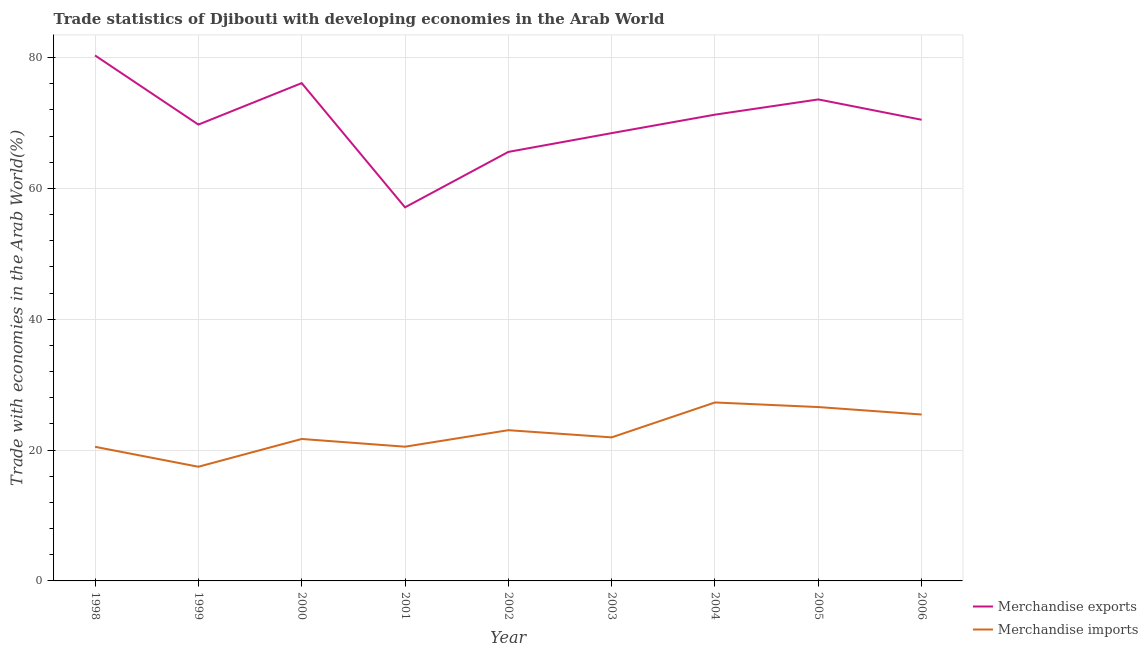What is the merchandise exports in 2002?
Ensure brevity in your answer.  65.59. Across all years, what is the maximum merchandise imports?
Provide a succinct answer. 27.28. Across all years, what is the minimum merchandise imports?
Your response must be concise. 17.46. In which year was the merchandise imports minimum?
Give a very brief answer. 1999. What is the total merchandise imports in the graph?
Ensure brevity in your answer.  204.48. What is the difference between the merchandise exports in 1998 and that in 2004?
Your response must be concise. 9.05. What is the difference between the merchandise imports in 1998 and the merchandise exports in 2001?
Your response must be concise. -36.61. What is the average merchandise exports per year?
Ensure brevity in your answer.  70.31. In the year 1999, what is the difference between the merchandise imports and merchandise exports?
Ensure brevity in your answer.  -52.31. What is the ratio of the merchandise imports in 2005 to that in 2006?
Offer a terse response. 1.04. Is the merchandise imports in 2000 less than that in 2004?
Make the answer very short. Yes. Is the difference between the merchandise exports in 2000 and 2003 greater than the difference between the merchandise imports in 2000 and 2003?
Give a very brief answer. Yes. What is the difference between the highest and the second highest merchandise exports?
Offer a very short reply. 4.23. What is the difference between the highest and the lowest merchandise imports?
Offer a terse response. 9.83. Is the sum of the merchandise imports in 2000 and 2003 greater than the maximum merchandise exports across all years?
Give a very brief answer. No. How many lines are there?
Provide a short and direct response. 2. Are the values on the major ticks of Y-axis written in scientific E-notation?
Provide a short and direct response. No. Where does the legend appear in the graph?
Provide a succinct answer. Bottom right. How many legend labels are there?
Offer a very short reply. 2. How are the legend labels stacked?
Your answer should be very brief. Vertical. What is the title of the graph?
Provide a succinct answer. Trade statistics of Djibouti with developing economies in the Arab World. Does "constant 2005 US$" appear as one of the legend labels in the graph?
Offer a terse response. No. What is the label or title of the Y-axis?
Give a very brief answer. Trade with economies in the Arab World(%). What is the Trade with economies in the Arab World(%) in Merchandise exports in 1998?
Provide a short and direct response. 80.34. What is the Trade with economies in the Arab World(%) of Merchandise imports in 1998?
Provide a succinct answer. 20.51. What is the Trade with economies in the Arab World(%) in Merchandise exports in 1999?
Make the answer very short. 69.77. What is the Trade with economies in the Arab World(%) of Merchandise imports in 1999?
Your answer should be compact. 17.46. What is the Trade with economies in the Arab World(%) in Merchandise exports in 2000?
Your answer should be very brief. 76.11. What is the Trade with economies in the Arab World(%) in Merchandise imports in 2000?
Ensure brevity in your answer.  21.7. What is the Trade with economies in the Arab World(%) in Merchandise exports in 2001?
Your response must be concise. 57.12. What is the Trade with economies in the Arab World(%) of Merchandise imports in 2001?
Ensure brevity in your answer.  20.52. What is the Trade with economies in the Arab World(%) in Merchandise exports in 2002?
Ensure brevity in your answer.  65.59. What is the Trade with economies in the Arab World(%) of Merchandise imports in 2002?
Provide a short and direct response. 23.04. What is the Trade with economies in the Arab World(%) in Merchandise exports in 2003?
Provide a succinct answer. 68.46. What is the Trade with economies in the Arab World(%) in Merchandise imports in 2003?
Provide a short and direct response. 21.95. What is the Trade with economies in the Arab World(%) in Merchandise exports in 2004?
Provide a succinct answer. 71.29. What is the Trade with economies in the Arab World(%) of Merchandise imports in 2004?
Ensure brevity in your answer.  27.28. What is the Trade with economies in the Arab World(%) in Merchandise exports in 2005?
Provide a succinct answer. 73.61. What is the Trade with economies in the Arab World(%) in Merchandise imports in 2005?
Make the answer very short. 26.58. What is the Trade with economies in the Arab World(%) of Merchandise exports in 2006?
Make the answer very short. 70.5. What is the Trade with economies in the Arab World(%) in Merchandise imports in 2006?
Keep it short and to the point. 25.44. Across all years, what is the maximum Trade with economies in the Arab World(%) of Merchandise exports?
Provide a short and direct response. 80.34. Across all years, what is the maximum Trade with economies in the Arab World(%) of Merchandise imports?
Offer a very short reply. 27.28. Across all years, what is the minimum Trade with economies in the Arab World(%) of Merchandise exports?
Provide a short and direct response. 57.12. Across all years, what is the minimum Trade with economies in the Arab World(%) in Merchandise imports?
Make the answer very short. 17.46. What is the total Trade with economies in the Arab World(%) of Merchandise exports in the graph?
Make the answer very short. 632.78. What is the total Trade with economies in the Arab World(%) in Merchandise imports in the graph?
Provide a short and direct response. 204.48. What is the difference between the Trade with economies in the Arab World(%) of Merchandise exports in 1998 and that in 1999?
Your answer should be very brief. 10.57. What is the difference between the Trade with economies in the Arab World(%) in Merchandise imports in 1998 and that in 1999?
Give a very brief answer. 3.05. What is the difference between the Trade with economies in the Arab World(%) in Merchandise exports in 1998 and that in 2000?
Give a very brief answer. 4.23. What is the difference between the Trade with economies in the Arab World(%) in Merchandise imports in 1998 and that in 2000?
Offer a very short reply. -1.2. What is the difference between the Trade with economies in the Arab World(%) in Merchandise exports in 1998 and that in 2001?
Provide a succinct answer. 23.22. What is the difference between the Trade with economies in the Arab World(%) of Merchandise imports in 1998 and that in 2001?
Your response must be concise. -0.02. What is the difference between the Trade with economies in the Arab World(%) of Merchandise exports in 1998 and that in 2002?
Make the answer very short. 14.75. What is the difference between the Trade with economies in the Arab World(%) of Merchandise imports in 1998 and that in 2002?
Offer a terse response. -2.54. What is the difference between the Trade with economies in the Arab World(%) of Merchandise exports in 1998 and that in 2003?
Give a very brief answer. 11.88. What is the difference between the Trade with economies in the Arab World(%) of Merchandise imports in 1998 and that in 2003?
Ensure brevity in your answer.  -1.44. What is the difference between the Trade with economies in the Arab World(%) of Merchandise exports in 1998 and that in 2004?
Keep it short and to the point. 9.05. What is the difference between the Trade with economies in the Arab World(%) in Merchandise imports in 1998 and that in 2004?
Keep it short and to the point. -6.78. What is the difference between the Trade with economies in the Arab World(%) of Merchandise exports in 1998 and that in 2005?
Give a very brief answer. 6.72. What is the difference between the Trade with economies in the Arab World(%) in Merchandise imports in 1998 and that in 2005?
Provide a succinct answer. -6.08. What is the difference between the Trade with economies in the Arab World(%) of Merchandise exports in 1998 and that in 2006?
Give a very brief answer. 9.84. What is the difference between the Trade with economies in the Arab World(%) of Merchandise imports in 1998 and that in 2006?
Ensure brevity in your answer.  -4.93. What is the difference between the Trade with economies in the Arab World(%) in Merchandise exports in 1999 and that in 2000?
Your answer should be compact. -6.34. What is the difference between the Trade with economies in the Arab World(%) of Merchandise imports in 1999 and that in 2000?
Your answer should be compact. -4.25. What is the difference between the Trade with economies in the Arab World(%) of Merchandise exports in 1999 and that in 2001?
Your response must be concise. 12.65. What is the difference between the Trade with economies in the Arab World(%) in Merchandise imports in 1999 and that in 2001?
Keep it short and to the point. -3.07. What is the difference between the Trade with economies in the Arab World(%) of Merchandise exports in 1999 and that in 2002?
Keep it short and to the point. 4.17. What is the difference between the Trade with economies in the Arab World(%) of Merchandise imports in 1999 and that in 2002?
Give a very brief answer. -5.59. What is the difference between the Trade with economies in the Arab World(%) in Merchandise exports in 1999 and that in 2003?
Provide a short and direct response. 1.3. What is the difference between the Trade with economies in the Arab World(%) of Merchandise imports in 1999 and that in 2003?
Keep it short and to the point. -4.49. What is the difference between the Trade with economies in the Arab World(%) of Merchandise exports in 1999 and that in 2004?
Provide a short and direct response. -1.52. What is the difference between the Trade with economies in the Arab World(%) in Merchandise imports in 1999 and that in 2004?
Your answer should be compact. -9.83. What is the difference between the Trade with economies in the Arab World(%) of Merchandise exports in 1999 and that in 2005?
Your answer should be compact. -3.85. What is the difference between the Trade with economies in the Arab World(%) of Merchandise imports in 1999 and that in 2005?
Keep it short and to the point. -9.13. What is the difference between the Trade with economies in the Arab World(%) in Merchandise exports in 1999 and that in 2006?
Keep it short and to the point. -0.74. What is the difference between the Trade with economies in the Arab World(%) of Merchandise imports in 1999 and that in 2006?
Ensure brevity in your answer.  -7.99. What is the difference between the Trade with economies in the Arab World(%) of Merchandise exports in 2000 and that in 2001?
Offer a terse response. 18.99. What is the difference between the Trade with economies in the Arab World(%) in Merchandise imports in 2000 and that in 2001?
Provide a succinct answer. 1.18. What is the difference between the Trade with economies in the Arab World(%) in Merchandise exports in 2000 and that in 2002?
Your answer should be compact. 10.52. What is the difference between the Trade with economies in the Arab World(%) in Merchandise imports in 2000 and that in 2002?
Provide a short and direct response. -1.34. What is the difference between the Trade with economies in the Arab World(%) in Merchandise exports in 2000 and that in 2003?
Your response must be concise. 7.65. What is the difference between the Trade with economies in the Arab World(%) in Merchandise imports in 2000 and that in 2003?
Provide a short and direct response. -0.24. What is the difference between the Trade with economies in the Arab World(%) of Merchandise exports in 2000 and that in 2004?
Ensure brevity in your answer.  4.82. What is the difference between the Trade with economies in the Arab World(%) in Merchandise imports in 2000 and that in 2004?
Provide a succinct answer. -5.58. What is the difference between the Trade with economies in the Arab World(%) of Merchandise exports in 2000 and that in 2005?
Ensure brevity in your answer.  2.49. What is the difference between the Trade with economies in the Arab World(%) of Merchandise imports in 2000 and that in 2005?
Your answer should be very brief. -4.88. What is the difference between the Trade with economies in the Arab World(%) of Merchandise exports in 2000 and that in 2006?
Make the answer very short. 5.6. What is the difference between the Trade with economies in the Arab World(%) in Merchandise imports in 2000 and that in 2006?
Your answer should be very brief. -3.74. What is the difference between the Trade with economies in the Arab World(%) in Merchandise exports in 2001 and that in 2002?
Provide a short and direct response. -8.47. What is the difference between the Trade with economies in the Arab World(%) in Merchandise imports in 2001 and that in 2002?
Your answer should be very brief. -2.52. What is the difference between the Trade with economies in the Arab World(%) of Merchandise exports in 2001 and that in 2003?
Give a very brief answer. -11.35. What is the difference between the Trade with economies in the Arab World(%) in Merchandise imports in 2001 and that in 2003?
Ensure brevity in your answer.  -1.43. What is the difference between the Trade with economies in the Arab World(%) of Merchandise exports in 2001 and that in 2004?
Give a very brief answer. -14.17. What is the difference between the Trade with economies in the Arab World(%) in Merchandise imports in 2001 and that in 2004?
Your response must be concise. -6.76. What is the difference between the Trade with economies in the Arab World(%) in Merchandise exports in 2001 and that in 2005?
Your answer should be very brief. -16.5. What is the difference between the Trade with economies in the Arab World(%) of Merchandise imports in 2001 and that in 2005?
Make the answer very short. -6.06. What is the difference between the Trade with economies in the Arab World(%) of Merchandise exports in 2001 and that in 2006?
Make the answer very short. -13.39. What is the difference between the Trade with economies in the Arab World(%) in Merchandise imports in 2001 and that in 2006?
Offer a terse response. -4.92. What is the difference between the Trade with economies in the Arab World(%) of Merchandise exports in 2002 and that in 2003?
Provide a short and direct response. -2.87. What is the difference between the Trade with economies in the Arab World(%) of Merchandise imports in 2002 and that in 2003?
Your answer should be compact. 1.1. What is the difference between the Trade with economies in the Arab World(%) in Merchandise exports in 2002 and that in 2004?
Give a very brief answer. -5.69. What is the difference between the Trade with economies in the Arab World(%) in Merchandise imports in 2002 and that in 2004?
Give a very brief answer. -4.24. What is the difference between the Trade with economies in the Arab World(%) in Merchandise exports in 2002 and that in 2005?
Make the answer very short. -8.02. What is the difference between the Trade with economies in the Arab World(%) of Merchandise imports in 2002 and that in 2005?
Ensure brevity in your answer.  -3.54. What is the difference between the Trade with economies in the Arab World(%) in Merchandise exports in 2002 and that in 2006?
Ensure brevity in your answer.  -4.91. What is the difference between the Trade with economies in the Arab World(%) of Merchandise imports in 2002 and that in 2006?
Make the answer very short. -2.4. What is the difference between the Trade with economies in the Arab World(%) of Merchandise exports in 2003 and that in 2004?
Keep it short and to the point. -2.82. What is the difference between the Trade with economies in the Arab World(%) in Merchandise imports in 2003 and that in 2004?
Your answer should be compact. -5.34. What is the difference between the Trade with economies in the Arab World(%) in Merchandise exports in 2003 and that in 2005?
Make the answer very short. -5.15. What is the difference between the Trade with economies in the Arab World(%) in Merchandise imports in 2003 and that in 2005?
Provide a short and direct response. -4.63. What is the difference between the Trade with economies in the Arab World(%) in Merchandise exports in 2003 and that in 2006?
Make the answer very short. -2.04. What is the difference between the Trade with economies in the Arab World(%) in Merchandise imports in 2003 and that in 2006?
Keep it short and to the point. -3.49. What is the difference between the Trade with economies in the Arab World(%) of Merchandise exports in 2004 and that in 2005?
Provide a succinct answer. -2.33. What is the difference between the Trade with economies in the Arab World(%) in Merchandise imports in 2004 and that in 2005?
Make the answer very short. 0.7. What is the difference between the Trade with economies in the Arab World(%) of Merchandise exports in 2004 and that in 2006?
Give a very brief answer. 0.78. What is the difference between the Trade with economies in the Arab World(%) of Merchandise imports in 2004 and that in 2006?
Offer a very short reply. 1.84. What is the difference between the Trade with economies in the Arab World(%) in Merchandise exports in 2005 and that in 2006?
Make the answer very short. 3.11. What is the difference between the Trade with economies in the Arab World(%) of Merchandise imports in 2005 and that in 2006?
Make the answer very short. 1.14. What is the difference between the Trade with economies in the Arab World(%) of Merchandise exports in 1998 and the Trade with economies in the Arab World(%) of Merchandise imports in 1999?
Make the answer very short. 62.88. What is the difference between the Trade with economies in the Arab World(%) in Merchandise exports in 1998 and the Trade with economies in the Arab World(%) in Merchandise imports in 2000?
Make the answer very short. 58.64. What is the difference between the Trade with economies in the Arab World(%) of Merchandise exports in 1998 and the Trade with economies in the Arab World(%) of Merchandise imports in 2001?
Your answer should be compact. 59.82. What is the difference between the Trade with economies in the Arab World(%) of Merchandise exports in 1998 and the Trade with economies in the Arab World(%) of Merchandise imports in 2002?
Offer a terse response. 57.29. What is the difference between the Trade with economies in the Arab World(%) of Merchandise exports in 1998 and the Trade with economies in the Arab World(%) of Merchandise imports in 2003?
Your answer should be compact. 58.39. What is the difference between the Trade with economies in the Arab World(%) in Merchandise exports in 1998 and the Trade with economies in the Arab World(%) in Merchandise imports in 2004?
Provide a short and direct response. 53.05. What is the difference between the Trade with economies in the Arab World(%) in Merchandise exports in 1998 and the Trade with economies in the Arab World(%) in Merchandise imports in 2005?
Offer a terse response. 53.76. What is the difference between the Trade with economies in the Arab World(%) of Merchandise exports in 1998 and the Trade with economies in the Arab World(%) of Merchandise imports in 2006?
Make the answer very short. 54.9. What is the difference between the Trade with economies in the Arab World(%) of Merchandise exports in 1999 and the Trade with economies in the Arab World(%) of Merchandise imports in 2000?
Provide a short and direct response. 48.06. What is the difference between the Trade with economies in the Arab World(%) in Merchandise exports in 1999 and the Trade with economies in the Arab World(%) in Merchandise imports in 2001?
Give a very brief answer. 49.24. What is the difference between the Trade with economies in the Arab World(%) in Merchandise exports in 1999 and the Trade with economies in the Arab World(%) in Merchandise imports in 2002?
Your response must be concise. 46.72. What is the difference between the Trade with economies in the Arab World(%) of Merchandise exports in 1999 and the Trade with economies in the Arab World(%) of Merchandise imports in 2003?
Ensure brevity in your answer.  47.82. What is the difference between the Trade with economies in the Arab World(%) of Merchandise exports in 1999 and the Trade with economies in the Arab World(%) of Merchandise imports in 2004?
Ensure brevity in your answer.  42.48. What is the difference between the Trade with economies in the Arab World(%) of Merchandise exports in 1999 and the Trade with economies in the Arab World(%) of Merchandise imports in 2005?
Your response must be concise. 43.18. What is the difference between the Trade with economies in the Arab World(%) of Merchandise exports in 1999 and the Trade with economies in the Arab World(%) of Merchandise imports in 2006?
Keep it short and to the point. 44.33. What is the difference between the Trade with economies in the Arab World(%) of Merchandise exports in 2000 and the Trade with economies in the Arab World(%) of Merchandise imports in 2001?
Provide a short and direct response. 55.59. What is the difference between the Trade with economies in the Arab World(%) in Merchandise exports in 2000 and the Trade with economies in the Arab World(%) in Merchandise imports in 2002?
Provide a short and direct response. 53.06. What is the difference between the Trade with economies in the Arab World(%) of Merchandise exports in 2000 and the Trade with economies in the Arab World(%) of Merchandise imports in 2003?
Make the answer very short. 54.16. What is the difference between the Trade with economies in the Arab World(%) of Merchandise exports in 2000 and the Trade with economies in the Arab World(%) of Merchandise imports in 2004?
Your response must be concise. 48.82. What is the difference between the Trade with economies in the Arab World(%) in Merchandise exports in 2000 and the Trade with economies in the Arab World(%) in Merchandise imports in 2005?
Offer a very short reply. 49.53. What is the difference between the Trade with economies in the Arab World(%) in Merchandise exports in 2000 and the Trade with economies in the Arab World(%) in Merchandise imports in 2006?
Your response must be concise. 50.67. What is the difference between the Trade with economies in the Arab World(%) in Merchandise exports in 2001 and the Trade with economies in the Arab World(%) in Merchandise imports in 2002?
Give a very brief answer. 34.07. What is the difference between the Trade with economies in the Arab World(%) in Merchandise exports in 2001 and the Trade with economies in the Arab World(%) in Merchandise imports in 2003?
Give a very brief answer. 35.17. What is the difference between the Trade with economies in the Arab World(%) of Merchandise exports in 2001 and the Trade with economies in the Arab World(%) of Merchandise imports in 2004?
Make the answer very short. 29.83. What is the difference between the Trade with economies in the Arab World(%) in Merchandise exports in 2001 and the Trade with economies in the Arab World(%) in Merchandise imports in 2005?
Give a very brief answer. 30.53. What is the difference between the Trade with economies in the Arab World(%) of Merchandise exports in 2001 and the Trade with economies in the Arab World(%) of Merchandise imports in 2006?
Keep it short and to the point. 31.68. What is the difference between the Trade with economies in the Arab World(%) in Merchandise exports in 2002 and the Trade with economies in the Arab World(%) in Merchandise imports in 2003?
Offer a terse response. 43.64. What is the difference between the Trade with economies in the Arab World(%) of Merchandise exports in 2002 and the Trade with economies in the Arab World(%) of Merchandise imports in 2004?
Ensure brevity in your answer.  38.31. What is the difference between the Trade with economies in the Arab World(%) in Merchandise exports in 2002 and the Trade with economies in the Arab World(%) in Merchandise imports in 2005?
Ensure brevity in your answer.  39.01. What is the difference between the Trade with economies in the Arab World(%) of Merchandise exports in 2002 and the Trade with economies in the Arab World(%) of Merchandise imports in 2006?
Your response must be concise. 40.15. What is the difference between the Trade with economies in the Arab World(%) in Merchandise exports in 2003 and the Trade with economies in the Arab World(%) in Merchandise imports in 2004?
Your answer should be very brief. 41.18. What is the difference between the Trade with economies in the Arab World(%) of Merchandise exports in 2003 and the Trade with economies in the Arab World(%) of Merchandise imports in 2005?
Your answer should be very brief. 41.88. What is the difference between the Trade with economies in the Arab World(%) in Merchandise exports in 2003 and the Trade with economies in the Arab World(%) in Merchandise imports in 2006?
Your response must be concise. 43.02. What is the difference between the Trade with economies in the Arab World(%) in Merchandise exports in 2004 and the Trade with economies in the Arab World(%) in Merchandise imports in 2005?
Offer a very short reply. 44.7. What is the difference between the Trade with economies in the Arab World(%) of Merchandise exports in 2004 and the Trade with economies in the Arab World(%) of Merchandise imports in 2006?
Your answer should be very brief. 45.85. What is the difference between the Trade with economies in the Arab World(%) in Merchandise exports in 2005 and the Trade with economies in the Arab World(%) in Merchandise imports in 2006?
Provide a succinct answer. 48.17. What is the average Trade with economies in the Arab World(%) of Merchandise exports per year?
Provide a short and direct response. 70.31. What is the average Trade with economies in the Arab World(%) of Merchandise imports per year?
Provide a succinct answer. 22.72. In the year 1998, what is the difference between the Trade with economies in the Arab World(%) of Merchandise exports and Trade with economies in the Arab World(%) of Merchandise imports?
Offer a very short reply. 59.83. In the year 1999, what is the difference between the Trade with economies in the Arab World(%) of Merchandise exports and Trade with economies in the Arab World(%) of Merchandise imports?
Keep it short and to the point. 52.31. In the year 2000, what is the difference between the Trade with economies in the Arab World(%) of Merchandise exports and Trade with economies in the Arab World(%) of Merchandise imports?
Provide a succinct answer. 54.4. In the year 2001, what is the difference between the Trade with economies in the Arab World(%) of Merchandise exports and Trade with economies in the Arab World(%) of Merchandise imports?
Your answer should be compact. 36.59. In the year 2002, what is the difference between the Trade with economies in the Arab World(%) of Merchandise exports and Trade with economies in the Arab World(%) of Merchandise imports?
Your response must be concise. 42.55. In the year 2003, what is the difference between the Trade with economies in the Arab World(%) in Merchandise exports and Trade with economies in the Arab World(%) in Merchandise imports?
Make the answer very short. 46.51. In the year 2004, what is the difference between the Trade with economies in the Arab World(%) of Merchandise exports and Trade with economies in the Arab World(%) of Merchandise imports?
Your answer should be very brief. 44. In the year 2005, what is the difference between the Trade with economies in the Arab World(%) in Merchandise exports and Trade with economies in the Arab World(%) in Merchandise imports?
Provide a succinct answer. 47.03. In the year 2006, what is the difference between the Trade with economies in the Arab World(%) in Merchandise exports and Trade with economies in the Arab World(%) in Merchandise imports?
Make the answer very short. 45.06. What is the ratio of the Trade with economies in the Arab World(%) of Merchandise exports in 1998 to that in 1999?
Your answer should be very brief. 1.15. What is the ratio of the Trade with economies in the Arab World(%) of Merchandise imports in 1998 to that in 1999?
Provide a short and direct response. 1.17. What is the ratio of the Trade with economies in the Arab World(%) of Merchandise exports in 1998 to that in 2000?
Your answer should be compact. 1.06. What is the ratio of the Trade with economies in the Arab World(%) in Merchandise imports in 1998 to that in 2000?
Provide a succinct answer. 0.94. What is the ratio of the Trade with economies in the Arab World(%) in Merchandise exports in 1998 to that in 2001?
Your response must be concise. 1.41. What is the ratio of the Trade with economies in the Arab World(%) of Merchandise imports in 1998 to that in 2001?
Your answer should be very brief. 1. What is the ratio of the Trade with economies in the Arab World(%) of Merchandise exports in 1998 to that in 2002?
Provide a short and direct response. 1.22. What is the ratio of the Trade with economies in the Arab World(%) in Merchandise imports in 1998 to that in 2002?
Give a very brief answer. 0.89. What is the ratio of the Trade with economies in the Arab World(%) of Merchandise exports in 1998 to that in 2003?
Your answer should be compact. 1.17. What is the ratio of the Trade with economies in the Arab World(%) in Merchandise imports in 1998 to that in 2003?
Give a very brief answer. 0.93. What is the ratio of the Trade with economies in the Arab World(%) of Merchandise exports in 1998 to that in 2004?
Offer a terse response. 1.13. What is the ratio of the Trade with economies in the Arab World(%) of Merchandise imports in 1998 to that in 2004?
Your answer should be compact. 0.75. What is the ratio of the Trade with economies in the Arab World(%) in Merchandise exports in 1998 to that in 2005?
Keep it short and to the point. 1.09. What is the ratio of the Trade with economies in the Arab World(%) in Merchandise imports in 1998 to that in 2005?
Make the answer very short. 0.77. What is the ratio of the Trade with economies in the Arab World(%) in Merchandise exports in 1998 to that in 2006?
Give a very brief answer. 1.14. What is the ratio of the Trade with economies in the Arab World(%) in Merchandise imports in 1998 to that in 2006?
Ensure brevity in your answer.  0.81. What is the ratio of the Trade with economies in the Arab World(%) of Merchandise exports in 1999 to that in 2000?
Your response must be concise. 0.92. What is the ratio of the Trade with economies in the Arab World(%) in Merchandise imports in 1999 to that in 2000?
Provide a short and direct response. 0.8. What is the ratio of the Trade with economies in the Arab World(%) in Merchandise exports in 1999 to that in 2001?
Offer a very short reply. 1.22. What is the ratio of the Trade with economies in the Arab World(%) of Merchandise imports in 1999 to that in 2001?
Offer a terse response. 0.85. What is the ratio of the Trade with economies in the Arab World(%) in Merchandise exports in 1999 to that in 2002?
Your response must be concise. 1.06. What is the ratio of the Trade with economies in the Arab World(%) of Merchandise imports in 1999 to that in 2002?
Your answer should be very brief. 0.76. What is the ratio of the Trade with economies in the Arab World(%) in Merchandise exports in 1999 to that in 2003?
Your response must be concise. 1.02. What is the ratio of the Trade with economies in the Arab World(%) of Merchandise imports in 1999 to that in 2003?
Your answer should be compact. 0.8. What is the ratio of the Trade with economies in the Arab World(%) in Merchandise exports in 1999 to that in 2004?
Your answer should be compact. 0.98. What is the ratio of the Trade with economies in the Arab World(%) of Merchandise imports in 1999 to that in 2004?
Your response must be concise. 0.64. What is the ratio of the Trade with economies in the Arab World(%) in Merchandise exports in 1999 to that in 2005?
Make the answer very short. 0.95. What is the ratio of the Trade with economies in the Arab World(%) of Merchandise imports in 1999 to that in 2005?
Provide a short and direct response. 0.66. What is the ratio of the Trade with economies in the Arab World(%) of Merchandise imports in 1999 to that in 2006?
Your response must be concise. 0.69. What is the ratio of the Trade with economies in the Arab World(%) of Merchandise exports in 2000 to that in 2001?
Your answer should be compact. 1.33. What is the ratio of the Trade with economies in the Arab World(%) of Merchandise imports in 2000 to that in 2001?
Your answer should be compact. 1.06. What is the ratio of the Trade with economies in the Arab World(%) in Merchandise exports in 2000 to that in 2002?
Make the answer very short. 1.16. What is the ratio of the Trade with economies in the Arab World(%) in Merchandise imports in 2000 to that in 2002?
Offer a terse response. 0.94. What is the ratio of the Trade with economies in the Arab World(%) in Merchandise exports in 2000 to that in 2003?
Make the answer very short. 1.11. What is the ratio of the Trade with economies in the Arab World(%) of Merchandise imports in 2000 to that in 2003?
Ensure brevity in your answer.  0.99. What is the ratio of the Trade with economies in the Arab World(%) in Merchandise exports in 2000 to that in 2004?
Provide a succinct answer. 1.07. What is the ratio of the Trade with economies in the Arab World(%) of Merchandise imports in 2000 to that in 2004?
Offer a very short reply. 0.8. What is the ratio of the Trade with economies in the Arab World(%) in Merchandise exports in 2000 to that in 2005?
Provide a short and direct response. 1.03. What is the ratio of the Trade with economies in the Arab World(%) of Merchandise imports in 2000 to that in 2005?
Ensure brevity in your answer.  0.82. What is the ratio of the Trade with economies in the Arab World(%) of Merchandise exports in 2000 to that in 2006?
Offer a terse response. 1.08. What is the ratio of the Trade with economies in the Arab World(%) in Merchandise imports in 2000 to that in 2006?
Provide a short and direct response. 0.85. What is the ratio of the Trade with economies in the Arab World(%) of Merchandise exports in 2001 to that in 2002?
Your answer should be very brief. 0.87. What is the ratio of the Trade with economies in the Arab World(%) of Merchandise imports in 2001 to that in 2002?
Keep it short and to the point. 0.89. What is the ratio of the Trade with economies in the Arab World(%) in Merchandise exports in 2001 to that in 2003?
Provide a succinct answer. 0.83. What is the ratio of the Trade with economies in the Arab World(%) in Merchandise imports in 2001 to that in 2003?
Provide a succinct answer. 0.94. What is the ratio of the Trade with economies in the Arab World(%) in Merchandise exports in 2001 to that in 2004?
Offer a terse response. 0.8. What is the ratio of the Trade with economies in the Arab World(%) of Merchandise imports in 2001 to that in 2004?
Your answer should be very brief. 0.75. What is the ratio of the Trade with economies in the Arab World(%) of Merchandise exports in 2001 to that in 2005?
Make the answer very short. 0.78. What is the ratio of the Trade with economies in the Arab World(%) of Merchandise imports in 2001 to that in 2005?
Your answer should be very brief. 0.77. What is the ratio of the Trade with economies in the Arab World(%) of Merchandise exports in 2001 to that in 2006?
Your answer should be very brief. 0.81. What is the ratio of the Trade with economies in the Arab World(%) in Merchandise imports in 2001 to that in 2006?
Offer a very short reply. 0.81. What is the ratio of the Trade with economies in the Arab World(%) of Merchandise exports in 2002 to that in 2003?
Give a very brief answer. 0.96. What is the ratio of the Trade with economies in the Arab World(%) of Merchandise imports in 2002 to that in 2003?
Your answer should be very brief. 1.05. What is the ratio of the Trade with economies in the Arab World(%) in Merchandise exports in 2002 to that in 2004?
Keep it short and to the point. 0.92. What is the ratio of the Trade with economies in the Arab World(%) of Merchandise imports in 2002 to that in 2004?
Give a very brief answer. 0.84. What is the ratio of the Trade with economies in the Arab World(%) of Merchandise exports in 2002 to that in 2005?
Offer a very short reply. 0.89. What is the ratio of the Trade with economies in the Arab World(%) in Merchandise imports in 2002 to that in 2005?
Your response must be concise. 0.87. What is the ratio of the Trade with economies in the Arab World(%) of Merchandise exports in 2002 to that in 2006?
Ensure brevity in your answer.  0.93. What is the ratio of the Trade with economies in the Arab World(%) of Merchandise imports in 2002 to that in 2006?
Ensure brevity in your answer.  0.91. What is the ratio of the Trade with economies in the Arab World(%) in Merchandise exports in 2003 to that in 2004?
Provide a succinct answer. 0.96. What is the ratio of the Trade with economies in the Arab World(%) in Merchandise imports in 2003 to that in 2004?
Provide a short and direct response. 0.8. What is the ratio of the Trade with economies in the Arab World(%) in Merchandise imports in 2003 to that in 2005?
Offer a very short reply. 0.83. What is the ratio of the Trade with economies in the Arab World(%) of Merchandise exports in 2003 to that in 2006?
Your response must be concise. 0.97. What is the ratio of the Trade with economies in the Arab World(%) of Merchandise imports in 2003 to that in 2006?
Ensure brevity in your answer.  0.86. What is the ratio of the Trade with economies in the Arab World(%) in Merchandise exports in 2004 to that in 2005?
Make the answer very short. 0.97. What is the ratio of the Trade with economies in the Arab World(%) of Merchandise imports in 2004 to that in 2005?
Keep it short and to the point. 1.03. What is the ratio of the Trade with economies in the Arab World(%) in Merchandise exports in 2004 to that in 2006?
Your response must be concise. 1.01. What is the ratio of the Trade with economies in the Arab World(%) in Merchandise imports in 2004 to that in 2006?
Offer a very short reply. 1.07. What is the ratio of the Trade with economies in the Arab World(%) in Merchandise exports in 2005 to that in 2006?
Offer a very short reply. 1.04. What is the ratio of the Trade with economies in the Arab World(%) in Merchandise imports in 2005 to that in 2006?
Offer a very short reply. 1.04. What is the difference between the highest and the second highest Trade with economies in the Arab World(%) of Merchandise exports?
Provide a short and direct response. 4.23. What is the difference between the highest and the second highest Trade with economies in the Arab World(%) in Merchandise imports?
Provide a succinct answer. 0.7. What is the difference between the highest and the lowest Trade with economies in the Arab World(%) of Merchandise exports?
Give a very brief answer. 23.22. What is the difference between the highest and the lowest Trade with economies in the Arab World(%) of Merchandise imports?
Make the answer very short. 9.83. 